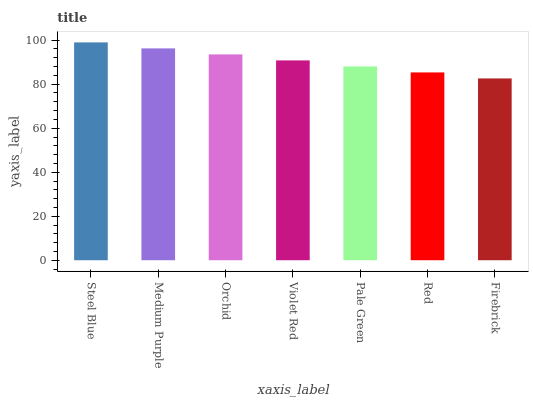Is Firebrick the minimum?
Answer yes or no. Yes. Is Steel Blue the maximum?
Answer yes or no. Yes. Is Medium Purple the minimum?
Answer yes or no. No. Is Medium Purple the maximum?
Answer yes or no. No. Is Steel Blue greater than Medium Purple?
Answer yes or no. Yes. Is Medium Purple less than Steel Blue?
Answer yes or no. Yes. Is Medium Purple greater than Steel Blue?
Answer yes or no. No. Is Steel Blue less than Medium Purple?
Answer yes or no. No. Is Violet Red the high median?
Answer yes or no. Yes. Is Violet Red the low median?
Answer yes or no. Yes. Is Medium Purple the high median?
Answer yes or no. No. Is Medium Purple the low median?
Answer yes or no. No. 